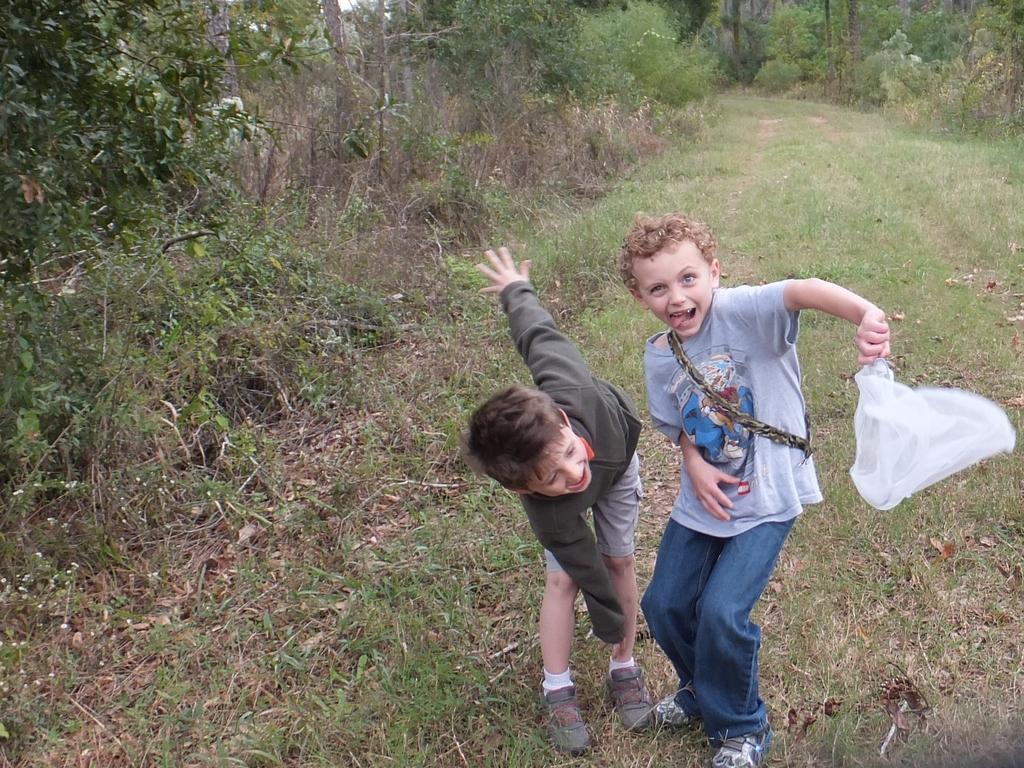In one or two sentences, can you explain what this image depicts? In this picture we can see two boys, they are smiling and the right side boy is holding a cover in his hand, in the background we can see few trees. 